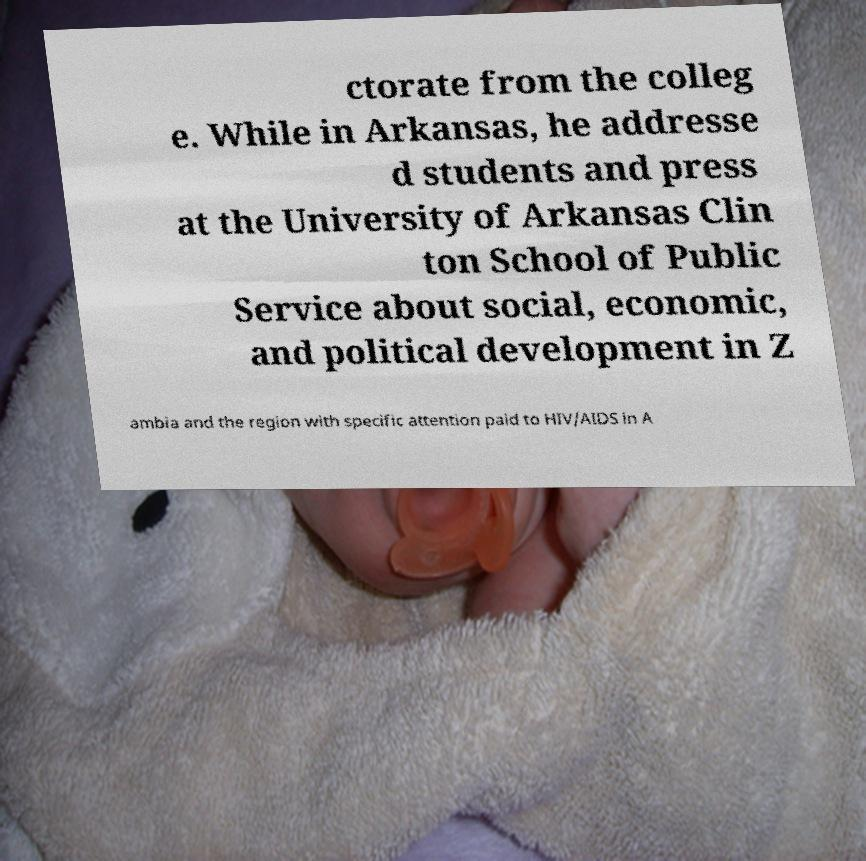Could you extract and type out the text from this image? ctorate from the colleg e. While in Arkansas, he addresse d students and press at the University of Arkansas Clin ton School of Public Service about social, economic, and political development in Z ambia and the region with specific attention paid to HIV/AIDS in A 